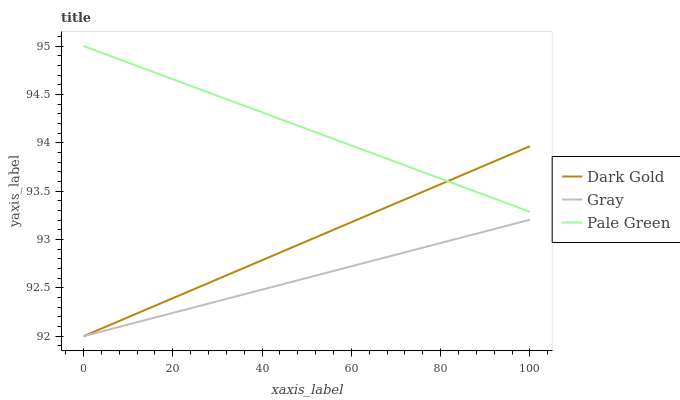Does Gray have the minimum area under the curve?
Answer yes or no. Yes. Does Pale Green have the maximum area under the curve?
Answer yes or no. Yes. Does Dark Gold have the minimum area under the curve?
Answer yes or no. No. Does Dark Gold have the maximum area under the curve?
Answer yes or no. No. Is Gray the smoothest?
Answer yes or no. Yes. Is Pale Green the roughest?
Answer yes or no. Yes. Is Dark Gold the smoothest?
Answer yes or no. No. Is Dark Gold the roughest?
Answer yes or no. No. Does Gray have the lowest value?
Answer yes or no. Yes. Does Pale Green have the lowest value?
Answer yes or no. No. Does Pale Green have the highest value?
Answer yes or no. Yes. Does Dark Gold have the highest value?
Answer yes or no. No. Is Gray less than Pale Green?
Answer yes or no. Yes. Is Pale Green greater than Gray?
Answer yes or no. Yes. Does Dark Gold intersect Pale Green?
Answer yes or no. Yes. Is Dark Gold less than Pale Green?
Answer yes or no. No. Is Dark Gold greater than Pale Green?
Answer yes or no. No. Does Gray intersect Pale Green?
Answer yes or no. No. 